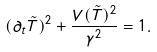<formula> <loc_0><loc_0><loc_500><loc_500>( \partial _ { t } \tilde { T } ) ^ { 2 } + \frac { V ( \tilde { T } ) ^ { 2 } } { \gamma ^ { 2 } } = 1 .</formula> 